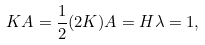Convert formula to latex. <formula><loc_0><loc_0><loc_500><loc_500>K A = \frac { 1 } { 2 } ( 2 K ) A = H \lambda = 1 ,</formula> 